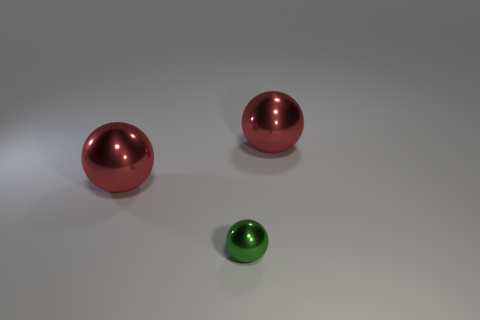Is there a purple object that has the same shape as the tiny green thing?
Ensure brevity in your answer.  No. Do the tiny object and the big thing that is on the right side of the small metallic object have the same shape?
Your answer should be compact. Yes. How many large red metallic balls are there?
Your response must be concise. 2. Are there any shiny spheres that have the same size as the green thing?
Make the answer very short. No. There is a large thing that is right of the small object; does it have the same color as the sphere that is left of the tiny green metallic thing?
Your answer should be very brief. Yes. How many matte objects are either tiny green balls or small blocks?
Provide a short and direct response. 0. What number of big red spheres are to the left of the big red metal sphere to the left of the red metallic thing that is to the right of the tiny object?
Offer a terse response. 0. How many other tiny metallic things have the same color as the tiny metallic thing?
Your answer should be very brief. 0. Does the red object on the left side of the green thing have the same size as the tiny object?
Your response must be concise. No. What number of objects are either tiny green shiny spheres or large spheres that are behind the green object?
Give a very brief answer. 3. 